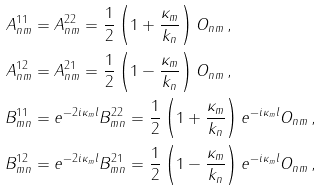Convert formula to latex. <formula><loc_0><loc_0><loc_500><loc_500>A ^ { 1 1 } _ { n m } & = A ^ { 2 2 } _ { n m } = \frac { 1 } { 2 } \left ( 1 + \frac { \kappa _ { m } } { k _ { n } } \right ) O _ { n m } \, , \\ A ^ { 1 2 } _ { n m } & = A ^ { 2 1 } _ { n m } = \frac { 1 } { 2 } \left ( 1 - \frac { \kappa _ { m } } { k _ { n } } \right ) O _ { n m } \, , \\ B ^ { 1 1 } _ { m n } & = e ^ { - 2 i \kappa _ { m } l } B ^ { 2 2 } _ { m n } = \frac { 1 } { 2 } \left ( 1 + \frac { \kappa _ { m } } { k _ { n } } \right ) e ^ { - i \kappa _ { m } l } O _ { n m } \, , \\ B ^ { 1 2 } _ { m n } & = e ^ { - 2 i \kappa _ { m } l } B ^ { 2 1 } _ { m n } = \frac { 1 } { 2 } \left ( 1 - \frac { \kappa _ { m } } { k _ { n } } \right ) e ^ { - i \kappa _ { m } l } O _ { n m } \, ,</formula> 